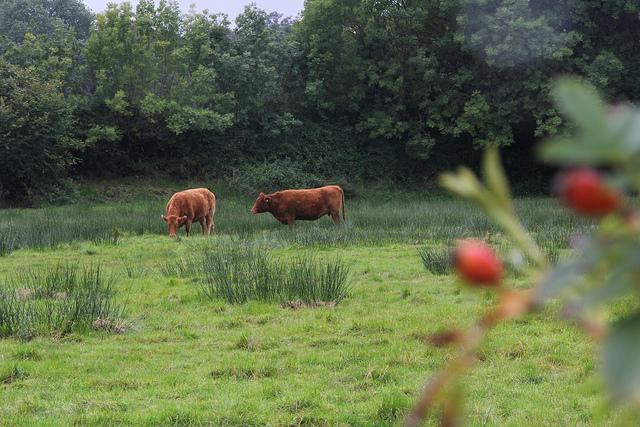What kind of trees are in the background?
Quick response, please. Green. Is there flowers out of focus?
Give a very brief answer. Yes. How many cows have their heads down eating grass?
Keep it brief. 1. 